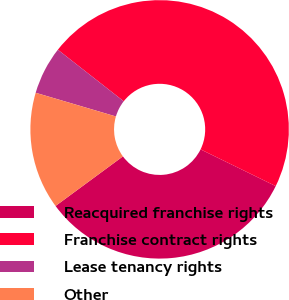<chart> <loc_0><loc_0><loc_500><loc_500><pie_chart><fcel>Reacquired franchise rights<fcel>Franchise contract rights<fcel>Lease tenancy rights<fcel>Other<nl><fcel>32.67%<fcel>46.67%<fcel>6.0%<fcel>14.67%<nl></chart> 